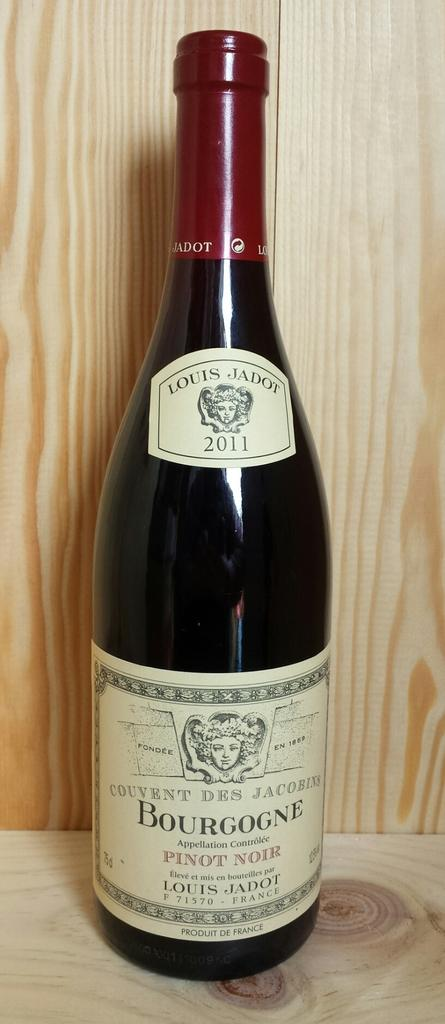<image>
Share a concise interpretation of the image provided. A bottle of Bourgogne pinot noir from France 